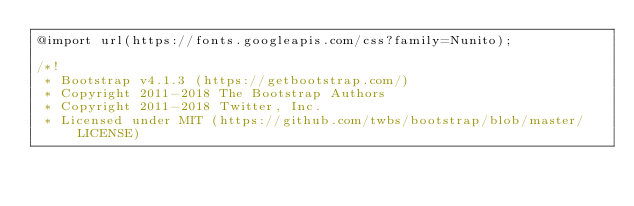<code> <loc_0><loc_0><loc_500><loc_500><_CSS_>@import url(https://fonts.googleapis.com/css?family=Nunito);

/*!
 * Bootstrap v4.1.3 (https://getbootstrap.com/)
 * Copyright 2011-2018 The Bootstrap Authors
 * Copyright 2011-2018 Twitter, Inc.
 * Licensed under MIT (https://github.com/twbs/bootstrap/blob/master/LICENSE)</code> 